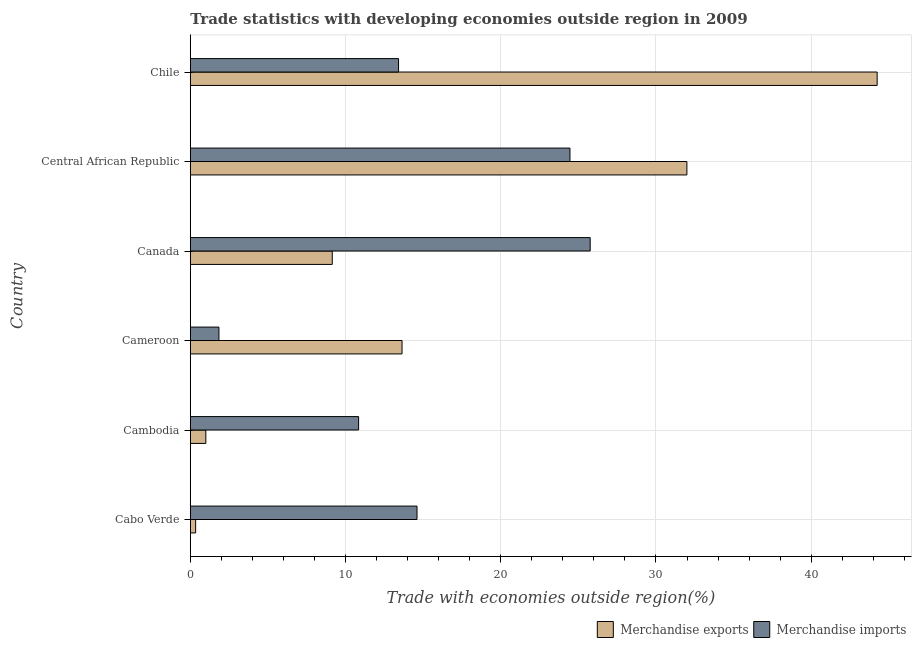How many different coloured bars are there?
Your response must be concise. 2. How many bars are there on the 2nd tick from the top?
Give a very brief answer. 2. What is the label of the 2nd group of bars from the top?
Provide a succinct answer. Central African Republic. In how many cases, is the number of bars for a given country not equal to the number of legend labels?
Ensure brevity in your answer.  0. What is the merchandise imports in Cabo Verde?
Ensure brevity in your answer.  14.61. Across all countries, what is the maximum merchandise imports?
Provide a short and direct response. 25.76. Across all countries, what is the minimum merchandise exports?
Your answer should be compact. 0.34. In which country was the merchandise exports maximum?
Offer a very short reply. Chile. In which country was the merchandise exports minimum?
Your response must be concise. Cabo Verde. What is the total merchandise imports in the graph?
Give a very brief answer. 90.93. What is the difference between the merchandise exports in Canada and that in Central African Republic?
Provide a short and direct response. -22.85. What is the difference between the merchandise imports in Central African Republic and the merchandise exports in Chile?
Offer a terse response. -19.79. What is the average merchandise imports per country?
Provide a short and direct response. 15.15. What is the difference between the merchandise exports and merchandise imports in Cabo Verde?
Offer a very short reply. -14.26. What is the ratio of the merchandise exports in Cameroon to that in Central African Republic?
Provide a short and direct response. 0.43. Is the merchandise imports in Central African Republic less than that in Chile?
Provide a succinct answer. No. What is the difference between the highest and the second highest merchandise imports?
Ensure brevity in your answer.  1.3. What is the difference between the highest and the lowest merchandise imports?
Provide a short and direct response. 23.92. Are all the bars in the graph horizontal?
Give a very brief answer. Yes. How many countries are there in the graph?
Provide a succinct answer. 6. Does the graph contain any zero values?
Your answer should be very brief. No. Does the graph contain grids?
Offer a terse response. Yes. Where does the legend appear in the graph?
Keep it short and to the point. Bottom right. What is the title of the graph?
Your answer should be very brief. Trade statistics with developing economies outside region in 2009. Does "Netherlands" appear as one of the legend labels in the graph?
Provide a short and direct response. No. What is the label or title of the X-axis?
Give a very brief answer. Trade with economies outside region(%). What is the label or title of the Y-axis?
Make the answer very short. Country. What is the Trade with economies outside region(%) of Merchandise exports in Cabo Verde?
Provide a succinct answer. 0.34. What is the Trade with economies outside region(%) in Merchandise imports in Cabo Verde?
Ensure brevity in your answer.  14.61. What is the Trade with economies outside region(%) in Merchandise exports in Cambodia?
Ensure brevity in your answer.  1. What is the Trade with economies outside region(%) in Merchandise imports in Cambodia?
Your response must be concise. 10.84. What is the Trade with economies outside region(%) in Merchandise exports in Cameroon?
Ensure brevity in your answer.  13.64. What is the Trade with economies outside region(%) of Merchandise imports in Cameroon?
Offer a very short reply. 1.84. What is the Trade with economies outside region(%) in Merchandise exports in Canada?
Give a very brief answer. 9.14. What is the Trade with economies outside region(%) of Merchandise imports in Canada?
Keep it short and to the point. 25.76. What is the Trade with economies outside region(%) in Merchandise exports in Central African Republic?
Your answer should be very brief. 31.99. What is the Trade with economies outside region(%) in Merchandise imports in Central African Republic?
Your answer should be very brief. 24.46. What is the Trade with economies outside region(%) of Merchandise exports in Chile?
Your answer should be very brief. 44.25. What is the Trade with economies outside region(%) in Merchandise imports in Chile?
Make the answer very short. 13.42. Across all countries, what is the maximum Trade with economies outside region(%) in Merchandise exports?
Your response must be concise. 44.25. Across all countries, what is the maximum Trade with economies outside region(%) in Merchandise imports?
Ensure brevity in your answer.  25.76. Across all countries, what is the minimum Trade with economies outside region(%) of Merchandise exports?
Ensure brevity in your answer.  0.34. Across all countries, what is the minimum Trade with economies outside region(%) in Merchandise imports?
Offer a very short reply. 1.84. What is the total Trade with economies outside region(%) in Merchandise exports in the graph?
Your answer should be compact. 100.37. What is the total Trade with economies outside region(%) of Merchandise imports in the graph?
Give a very brief answer. 90.93. What is the difference between the Trade with economies outside region(%) in Merchandise exports in Cabo Verde and that in Cambodia?
Make the answer very short. -0.66. What is the difference between the Trade with economies outside region(%) in Merchandise imports in Cabo Verde and that in Cambodia?
Your answer should be very brief. 3.76. What is the difference between the Trade with economies outside region(%) in Merchandise exports in Cabo Verde and that in Cameroon?
Your answer should be very brief. -13.3. What is the difference between the Trade with economies outside region(%) of Merchandise imports in Cabo Verde and that in Cameroon?
Provide a succinct answer. 12.76. What is the difference between the Trade with economies outside region(%) in Merchandise exports in Cabo Verde and that in Canada?
Offer a terse response. -8.8. What is the difference between the Trade with economies outside region(%) in Merchandise imports in Cabo Verde and that in Canada?
Your answer should be very brief. -11.16. What is the difference between the Trade with economies outside region(%) in Merchandise exports in Cabo Verde and that in Central African Republic?
Ensure brevity in your answer.  -31.65. What is the difference between the Trade with economies outside region(%) of Merchandise imports in Cabo Verde and that in Central African Republic?
Offer a terse response. -9.85. What is the difference between the Trade with economies outside region(%) of Merchandise exports in Cabo Verde and that in Chile?
Offer a terse response. -43.9. What is the difference between the Trade with economies outside region(%) of Merchandise imports in Cabo Verde and that in Chile?
Make the answer very short. 1.19. What is the difference between the Trade with economies outside region(%) of Merchandise exports in Cambodia and that in Cameroon?
Provide a succinct answer. -12.64. What is the difference between the Trade with economies outside region(%) of Merchandise imports in Cambodia and that in Cameroon?
Offer a terse response. 9. What is the difference between the Trade with economies outside region(%) in Merchandise exports in Cambodia and that in Canada?
Ensure brevity in your answer.  -8.14. What is the difference between the Trade with economies outside region(%) in Merchandise imports in Cambodia and that in Canada?
Your answer should be very brief. -14.92. What is the difference between the Trade with economies outside region(%) of Merchandise exports in Cambodia and that in Central African Republic?
Provide a short and direct response. -30.99. What is the difference between the Trade with economies outside region(%) of Merchandise imports in Cambodia and that in Central African Republic?
Provide a succinct answer. -13.61. What is the difference between the Trade with economies outside region(%) in Merchandise exports in Cambodia and that in Chile?
Make the answer very short. -43.25. What is the difference between the Trade with economies outside region(%) of Merchandise imports in Cambodia and that in Chile?
Give a very brief answer. -2.57. What is the difference between the Trade with economies outside region(%) in Merchandise exports in Cameroon and that in Canada?
Your answer should be very brief. 4.5. What is the difference between the Trade with economies outside region(%) of Merchandise imports in Cameroon and that in Canada?
Give a very brief answer. -23.92. What is the difference between the Trade with economies outside region(%) in Merchandise exports in Cameroon and that in Central African Republic?
Your answer should be very brief. -18.35. What is the difference between the Trade with economies outside region(%) of Merchandise imports in Cameroon and that in Central African Republic?
Keep it short and to the point. -22.61. What is the difference between the Trade with economies outside region(%) in Merchandise exports in Cameroon and that in Chile?
Give a very brief answer. -30.61. What is the difference between the Trade with economies outside region(%) of Merchandise imports in Cameroon and that in Chile?
Your answer should be compact. -11.57. What is the difference between the Trade with economies outside region(%) of Merchandise exports in Canada and that in Central African Republic?
Your answer should be compact. -22.85. What is the difference between the Trade with economies outside region(%) of Merchandise imports in Canada and that in Central African Republic?
Provide a succinct answer. 1.3. What is the difference between the Trade with economies outside region(%) in Merchandise exports in Canada and that in Chile?
Keep it short and to the point. -35.1. What is the difference between the Trade with economies outside region(%) in Merchandise imports in Canada and that in Chile?
Keep it short and to the point. 12.35. What is the difference between the Trade with economies outside region(%) of Merchandise exports in Central African Republic and that in Chile?
Give a very brief answer. -12.26. What is the difference between the Trade with economies outside region(%) of Merchandise imports in Central African Republic and that in Chile?
Make the answer very short. 11.04. What is the difference between the Trade with economies outside region(%) in Merchandise exports in Cabo Verde and the Trade with economies outside region(%) in Merchandise imports in Cambodia?
Make the answer very short. -10.5. What is the difference between the Trade with economies outside region(%) in Merchandise exports in Cabo Verde and the Trade with economies outside region(%) in Merchandise imports in Cameroon?
Offer a very short reply. -1.5. What is the difference between the Trade with economies outside region(%) of Merchandise exports in Cabo Verde and the Trade with economies outside region(%) of Merchandise imports in Canada?
Provide a succinct answer. -25.42. What is the difference between the Trade with economies outside region(%) of Merchandise exports in Cabo Verde and the Trade with economies outside region(%) of Merchandise imports in Central African Republic?
Your response must be concise. -24.11. What is the difference between the Trade with economies outside region(%) in Merchandise exports in Cabo Verde and the Trade with economies outside region(%) in Merchandise imports in Chile?
Offer a very short reply. -13.07. What is the difference between the Trade with economies outside region(%) of Merchandise exports in Cambodia and the Trade with economies outside region(%) of Merchandise imports in Cameroon?
Provide a short and direct response. -0.84. What is the difference between the Trade with economies outside region(%) in Merchandise exports in Cambodia and the Trade with economies outside region(%) in Merchandise imports in Canada?
Provide a short and direct response. -24.76. What is the difference between the Trade with economies outside region(%) of Merchandise exports in Cambodia and the Trade with economies outside region(%) of Merchandise imports in Central African Republic?
Your answer should be very brief. -23.46. What is the difference between the Trade with economies outside region(%) in Merchandise exports in Cambodia and the Trade with economies outside region(%) in Merchandise imports in Chile?
Your answer should be compact. -12.42. What is the difference between the Trade with economies outside region(%) of Merchandise exports in Cameroon and the Trade with economies outside region(%) of Merchandise imports in Canada?
Offer a very short reply. -12.12. What is the difference between the Trade with economies outside region(%) of Merchandise exports in Cameroon and the Trade with economies outside region(%) of Merchandise imports in Central African Republic?
Your answer should be compact. -10.82. What is the difference between the Trade with economies outside region(%) of Merchandise exports in Cameroon and the Trade with economies outside region(%) of Merchandise imports in Chile?
Offer a terse response. 0.22. What is the difference between the Trade with economies outside region(%) of Merchandise exports in Canada and the Trade with economies outside region(%) of Merchandise imports in Central African Republic?
Your response must be concise. -15.31. What is the difference between the Trade with economies outside region(%) of Merchandise exports in Canada and the Trade with economies outside region(%) of Merchandise imports in Chile?
Your response must be concise. -4.27. What is the difference between the Trade with economies outside region(%) in Merchandise exports in Central African Republic and the Trade with economies outside region(%) in Merchandise imports in Chile?
Provide a succinct answer. 18.58. What is the average Trade with economies outside region(%) in Merchandise exports per country?
Your answer should be very brief. 16.73. What is the average Trade with economies outside region(%) of Merchandise imports per country?
Your response must be concise. 15.15. What is the difference between the Trade with economies outside region(%) of Merchandise exports and Trade with economies outside region(%) of Merchandise imports in Cabo Verde?
Your answer should be compact. -14.26. What is the difference between the Trade with economies outside region(%) of Merchandise exports and Trade with economies outside region(%) of Merchandise imports in Cambodia?
Offer a very short reply. -9.84. What is the difference between the Trade with economies outside region(%) in Merchandise exports and Trade with economies outside region(%) in Merchandise imports in Cameroon?
Offer a very short reply. 11.8. What is the difference between the Trade with economies outside region(%) in Merchandise exports and Trade with economies outside region(%) in Merchandise imports in Canada?
Make the answer very short. -16.62. What is the difference between the Trade with economies outside region(%) of Merchandise exports and Trade with economies outside region(%) of Merchandise imports in Central African Republic?
Provide a short and direct response. 7.53. What is the difference between the Trade with economies outside region(%) of Merchandise exports and Trade with economies outside region(%) of Merchandise imports in Chile?
Keep it short and to the point. 30.83. What is the ratio of the Trade with economies outside region(%) of Merchandise exports in Cabo Verde to that in Cambodia?
Offer a terse response. 0.34. What is the ratio of the Trade with economies outside region(%) of Merchandise imports in Cabo Verde to that in Cambodia?
Your response must be concise. 1.35. What is the ratio of the Trade with economies outside region(%) in Merchandise exports in Cabo Verde to that in Cameroon?
Keep it short and to the point. 0.03. What is the ratio of the Trade with economies outside region(%) in Merchandise imports in Cabo Verde to that in Cameroon?
Provide a short and direct response. 7.92. What is the ratio of the Trade with economies outside region(%) of Merchandise exports in Cabo Verde to that in Canada?
Offer a terse response. 0.04. What is the ratio of the Trade with economies outside region(%) in Merchandise imports in Cabo Verde to that in Canada?
Offer a terse response. 0.57. What is the ratio of the Trade with economies outside region(%) in Merchandise exports in Cabo Verde to that in Central African Republic?
Keep it short and to the point. 0.01. What is the ratio of the Trade with economies outside region(%) in Merchandise imports in Cabo Verde to that in Central African Republic?
Offer a very short reply. 0.6. What is the ratio of the Trade with economies outside region(%) in Merchandise exports in Cabo Verde to that in Chile?
Make the answer very short. 0.01. What is the ratio of the Trade with economies outside region(%) of Merchandise imports in Cabo Verde to that in Chile?
Your answer should be very brief. 1.09. What is the ratio of the Trade with economies outside region(%) of Merchandise exports in Cambodia to that in Cameroon?
Your answer should be compact. 0.07. What is the ratio of the Trade with economies outside region(%) of Merchandise imports in Cambodia to that in Cameroon?
Provide a short and direct response. 5.88. What is the ratio of the Trade with economies outside region(%) in Merchandise exports in Cambodia to that in Canada?
Ensure brevity in your answer.  0.11. What is the ratio of the Trade with economies outside region(%) in Merchandise imports in Cambodia to that in Canada?
Make the answer very short. 0.42. What is the ratio of the Trade with economies outside region(%) of Merchandise exports in Cambodia to that in Central African Republic?
Your answer should be very brief. 0.03. What is the ratio of the Trade with economies outside region(%) in Merchandise imports in Cambodia to that in Central African Republic?
Keep it short and to the point. 0.44. What is the ratio of the Trade with economies outside region(%) of Merchandise exports in Cambodia to that in Chile?
Your answer should be very brief. 0.02. What is the ratio of the Trade with economies outside region(%) of Merchandise imports in Cambodia to that in Chile?
Your response must be concise. 0.81. What is the ratio of the Trade with economies outside region(%) of Merchandise exports in Cameroon to that in Canada?
Your response must be concise. 1.49. What is the ratio of the Trade with economies outside region(%) in Merchandise imports in Cameroon to that in Canada?
Make the answer very short. 0.07. What is the ratio of the Trade with economies outside region(%) of Merchandise exports in Cameroon to that in Central African Republic?
Provide a succinct answer. 0.43. What is the ratio of the Trade with economies outside region(%) in Merchandise imports in Cameroon to that in Central African Republic?
Provide a short and direct response. 0.08. What is the ratio of the Trade with economies outside region(%) of Merchandise exports in Cameroon to that in Chile?
Your response must be concise. 0.31. What is the ratio of the Trade with economies outside region(%) in Merchandise imports in Cameroon to that in Chile?
Your answer should be compact. 0.14. What is the ratio of the Trade with economies outside region(%) in Merchandise exports in Canada to that in Central African Republic?
Provide a succinct answer. 0.29. What is the ratio of the Trade with economies outside region(%) in Merchandise imports in Canada to that in Central African Republic?
Keep it short and to the point. 1.05. What is the ratio of the Trade with economies outside region(%) of Merchandise exports in Canada to that in Chile?
Your response must be concise. 0.21. What is the ratio of the Trade with economies outside region(%) in Merchandise imports in Canada to that in Chile?
Make the answer very short. 1.92. What is the ratio of the Trade with economies outside region(%) in Merchandise exports in Central African Republic to that in Chile?
Your response must be concise. 0.72. What is the ratio of the Trade with economies outside region(%) of Merchandise imports in Central African Republic to that in Chile?
Give a very brief answer. 1.82. What is the difference between the highest and the second highest Trade with economies outside region(%) in Merchandise exports?
Your response must be concise. 12.26. What is the difference between the highest and the second highest Trade with economies outside region(%) in Merchandise imports?
Your response must be concise. 1.3. What is the difference between the highest and the lowest Trade with economies outside region(%) of Merchandise exports?
Give a very brief answer. 43.9. What is the difference between the highest and the lowest Trade with economies outside region(%) of Merchandise imports?
Offer a very short reply. 23.92. 